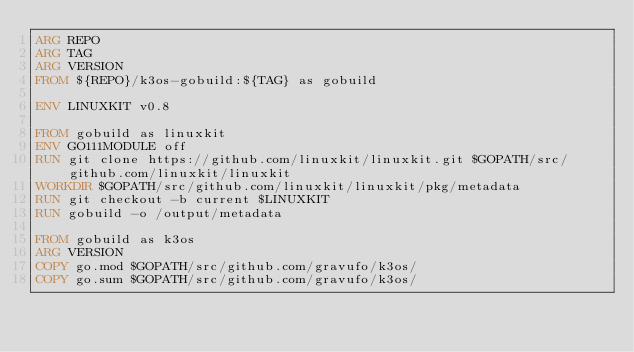<code> <loc_0><loc_0><loc_500><loc_500><_Dockerfile_>ARG REPO
ARG TAG
ARG VERSION
FROM ${REPO}/k3os-gobuild:${TAG} as gobuild

ENV LINUXKIT v0.8

FROM gobuild as linuxkit
ENV GO111MODULE off
RUN git clone https://github.com/linuxkit/linuxkit.git $GOPATH/src/github.com/linuxkit/linuxkit
WORKDIR $GOPATH/src/github.com/linuxkit/linuxkit/pkg/metadata
RUN git checkout -b current $LINUXKIT
RUN gobuild -o /output/metadata

FROM gobuild as k3os
ARG VERSION
COPY go.mod $GOPATH/src/github.com/gravufo/k3os/
COPY go.sum $GOPATH/src/github.com/gravufo/k3os/</code> 